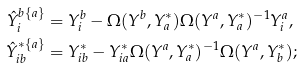<formula> <loc_0><loc_0><loc_500><loc_500>\hat { Y } _ { i } ^ { b \{ a \} } & = Y _ { i } ^ { b } - \Omega ( Y ^ { b } , Y ^ { * } _ { a } ) \Omega ( Y ^ { a } , Y ^ { * } _ { a } ) ^ { - 1 } Y ^ { a } _ { i } , \\ \hat { Y } _ { i b } ^ { * \{ a \} } & = Y _ { i b } ^ { * } - Y ^ { * } _ { i a } \Omega ( Y ^ { a } , Y ^ { * } _ { a } ) ^ { - 1 } \Omega ( Y ^ { a } , Y _ { b } ^ { * } ) ;</formula> 